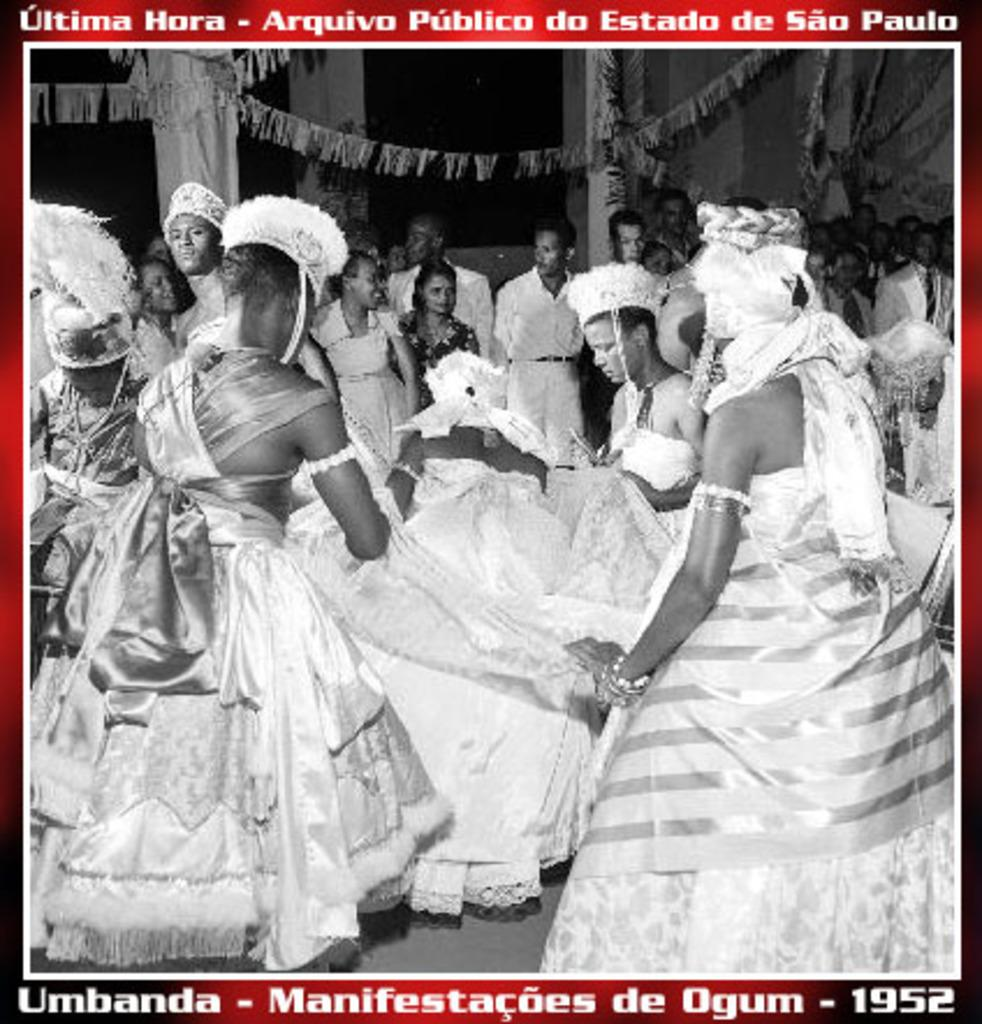How many people are in the image? There are people in the image, but the exact number is not specified. What are some people wearing in the image? Some people are wearing costumes in the image. What can be found on the image besides people? There is text on the image. What color scheme is used in the image? The image is black and white in color. What type of transport can be seen in the image? There is no transport visible in the image; it only features people, costumes, text, and a black and white color scheme. Can you tell me what kind of notebook is being used by the people in the image? There is no notebook present in the image. 